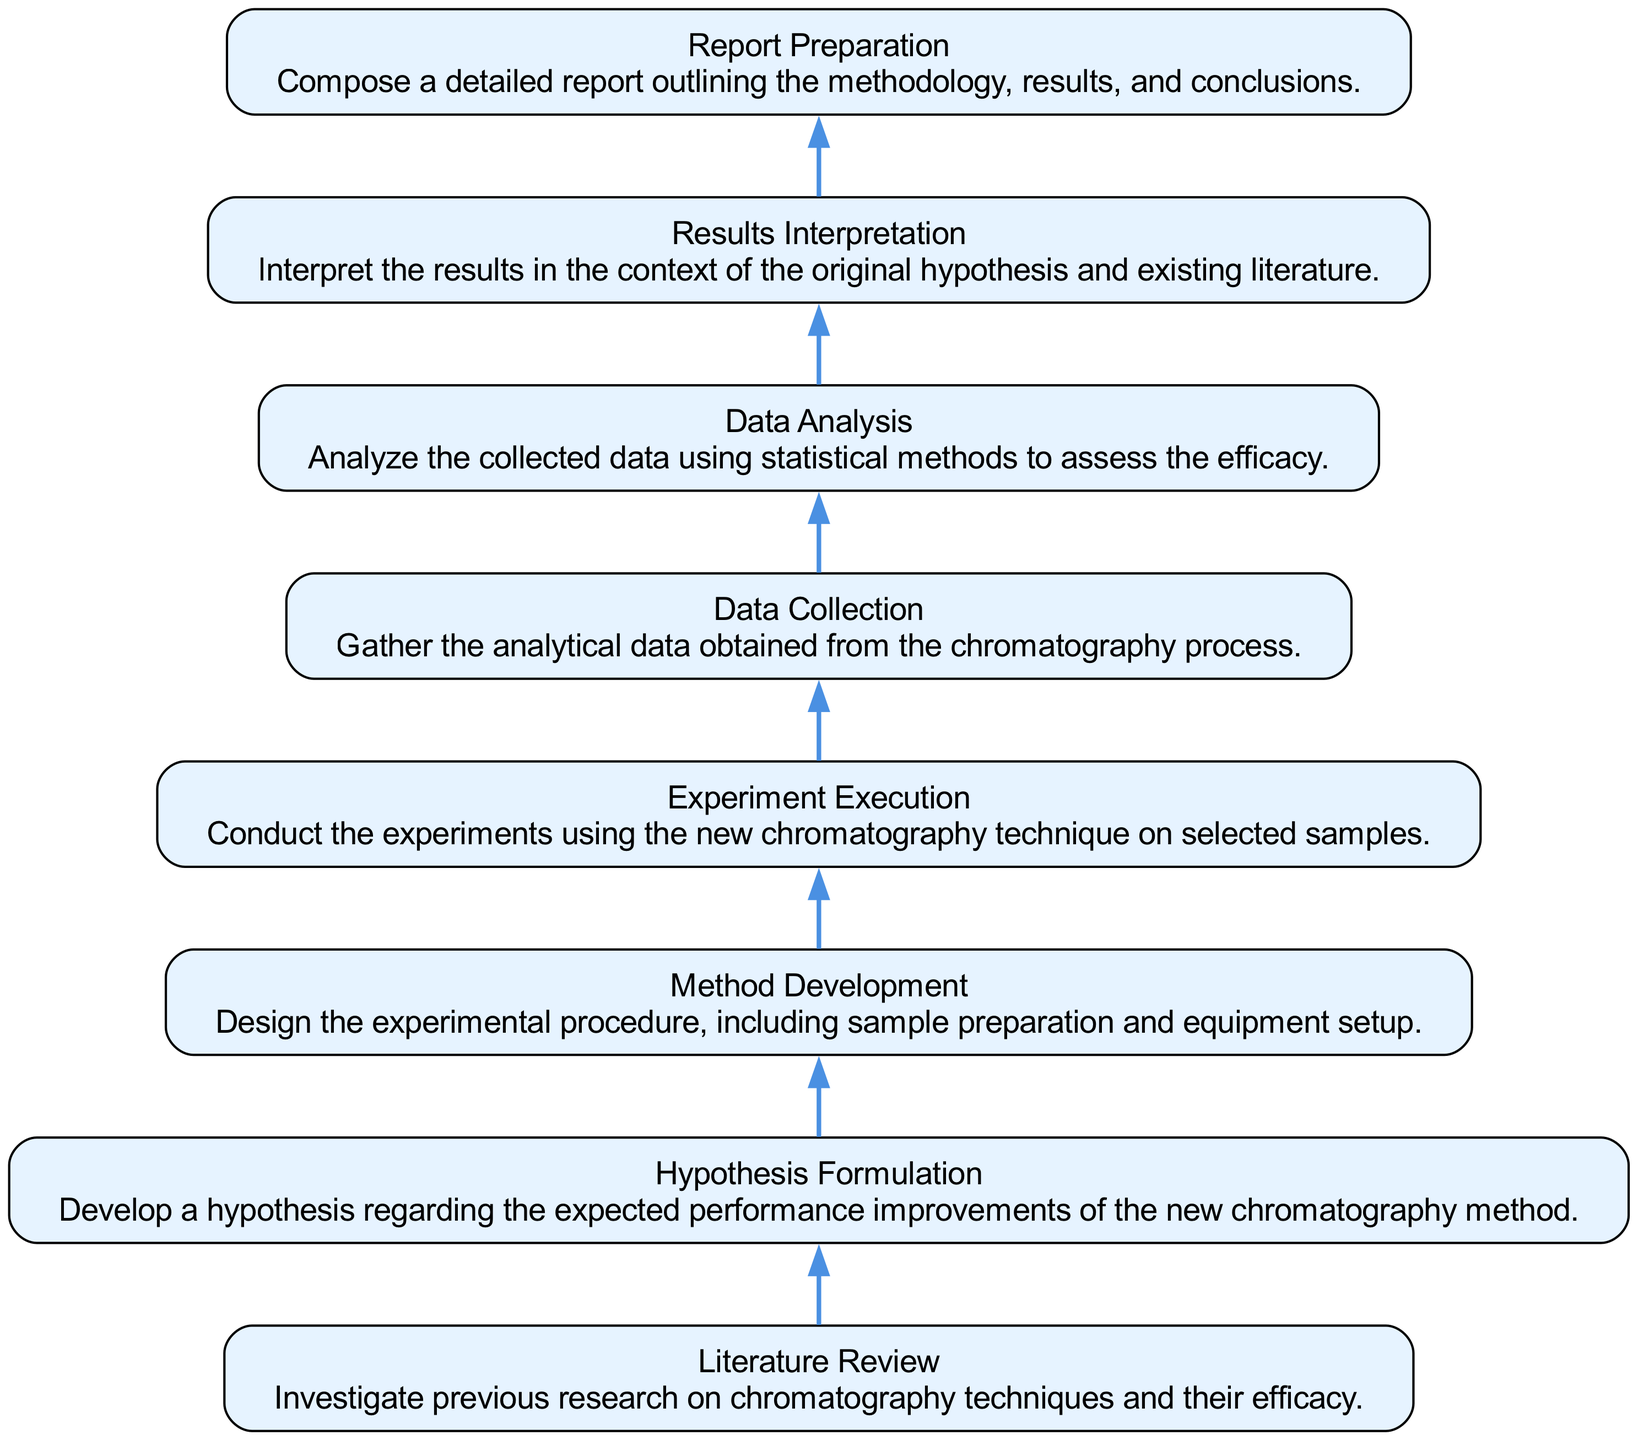What is the first step in the workflow? The first step, as seen at the bottom of the flow chart, is the "Literature Review." It's positioned at the start of the workflow indicating the foundational phase of the experiment.
Answer: Literature Review How many total steps are outlined in the diagram? The diagram includes a total of eight distinct steps, each representing a component of the workflow in conducting the chromatography experiment.
Answer: Eight What is the last step in the experimental workflow? The last step, located at the top of the flow chart, is "Report Preparation." This indicates that preparing a report is the final action following all experimental analysis.
Answer: Report Preparation Which step directly follows "Experiment Execution"? The step that directly follows "Experiment Execution" is "Data Collection." This indicates the sequence where after executing the experiments, data gathering occurs.
Answer: Data Collection What is the relationship between "Hypothesis Formulation" and "Results Interpretation"? "Hypothesis Formulation" precedes "Results Interpretation" in the workflow. The relationship indicates that interpretation of results is done in context with the hypothesis initially set.
Answer: Preceding In which step is statistical analysis applied? Statistical analysis is applied in the "Data Analysis" step. This indicates that this phase focuses on evaluating the data gathered using statistical methods.
Answer: Data Analysis Which node describes the setup of experimental procedures? The "Method Development" node describes the setup of the experimental procedures necessary to conduct the experiment, including how the samples will be prepared and equipment setup.
Answer: Method Development What does the "Data Analysis" step assess? The "Data Analysis" step assesses the efficacy of the new chromatography technique based on the data collected from the experiment.
Answer: Efficacy Which two steps are directly connected before "Results Interpretation"? The two steps directly connected before "Results Interpretation" are "Data Analysis" and "Hypothesis Formulation." This signifies that data analysis influences the interpretation of results concerning the hypothesis.
Answer: Data Analysis and Hypothesis Formulation 